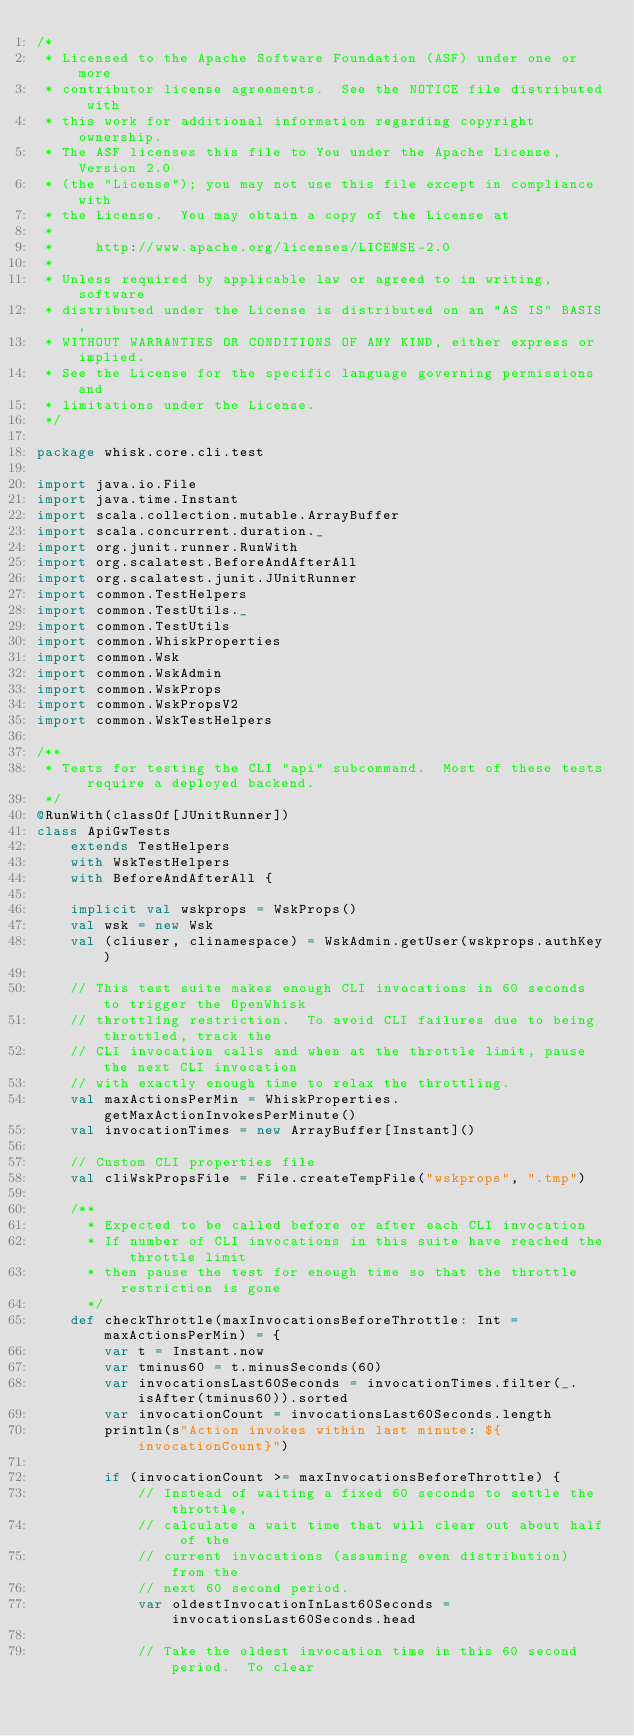Convert code to text. <code><loc_0><loc_0><loc_500><loc_500><_Scala_>/*
 * Licensed to the Apache Software Foundation (ASF) under one or more
 * contributor license agreements.  See the NOTICE file distributed with
 * this work for additional information regarding copyright ownership.
 * The ASF licenses this file to You under the Apache License, Version 2.0
 * (the "License"); you may not use this file except in compliance with
 * the License.  You may obtain a copy of the License at
 *
 *     http://www.apache.org/licenses/LICENSE-2.0
 *
 * Unless required by applicable law or agreed to in writing, software
 * distributed under the License is distributed on an "AS IS" BASIS,
 * WITHOUT WARRANTIES OR CONDITIONS OF ANY KIND, either express or implied.
 * See the License for the specific language governing permissions and
 * limitations under the License.
 */

package whisk.core.cli.test

import java.io.File
import java.time.Instant
import scala.collection.mutable.ArrayBuffer
import scala.concurrent.duration._
import org.junit.runner.RunWith
import org.scalatest.BeforeAndAfterAll
import org.scalatest.junit.JUnitRunner
import common.TestHelpers
import common.TestUtils._
import common.TestUtils
import common.WhiskProperties
import common.Wsk
import common.WskAdmin
import common.WskProps
import common.WskPropsV2
import common.WskTestHelpers

/**
 * Tests for testing the CLI "api" subcommand.  Most of these tests require a deployed backend.
 */
@RunWith(classOf[JUnitRunner])
class ApiGwTests
    extends TestHelpers
    with WskTestHelpers
    with BeforeAndAfterAll {

    implicit val wskprops = WskProps()
    val wsk = new Wsk
    val (cliuser, clinamespace) = WskAdmin.getUser(wskprops.authKey)

    // This test suite makes enough CLI invocations in 60 seconds to trigger the OpenWhisk
    // throttling restriction.  To avoid CLI failures due to being throttled, track the
    // CLI invocation calls and when at the throttle limit, pause the next CLI invocation
    // with exactly enough time to relax the throttling.
    val maxActionsPerMin = WhiskProperties.getMaxActionInvokesPerMinute()
    val invocationTimes = new ArrayBuffer[Instant]()

    // Custom CLI properties file
    val cliWskPropsFile = File.createTempFile("wskprops", ".tmp")

    /**
      * Expected to be called before or after each CLI invocation
      * If number of CLI invocations in this suite have reached the throttle limit
      * then pause the test for enough time so that the throttle restriction is gone
      */
    def checkThrottle(maxInvocationsBeforeThrottle: Int = maxActionsPerMin) = {
        var t = Instant.now
        var tminus60 = t.minusSeconds(60)
        var invocationsLast60Seconds = invocationTimes.filter(_.isAfter(tminus60)).sorted
        var invocationCount = invocationsLast60Seconds.length
        println(s"Action invokes within last minute: ${invocationCount}")

        if (invocationCount >= maxInvocationsBeforeThrottle) {
            // Instead of waiting a fixed 60 seconds to settle the throttle,
            // calculate a wait time that will clear out about half of the
            // current invocations (assuming even distribution) from the
            // next 60 second period.
            var oldestInvocationInLast60Seconds = invocationsLast60Seconds.head

            // Take the oldest invocation time in this 60 second period.  To clear</code> 